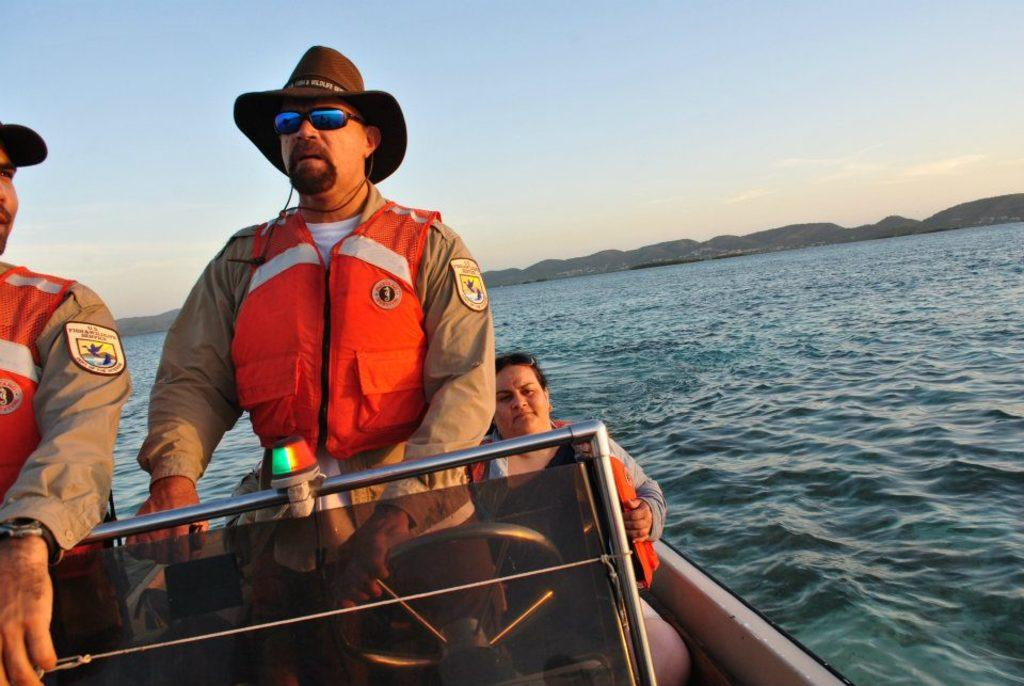How many people are in the boat in the image? There are three persons in a boat in the image. What is the boat sailing on? The boat is sailing on the sea. What can be seen in the background of the image? There is a hill and the sky visible in the background of the image. What type of street can be seen in the image? There is no street present in the image; it features a boat sailing on the sea with a hill and the sky visible in the background. 